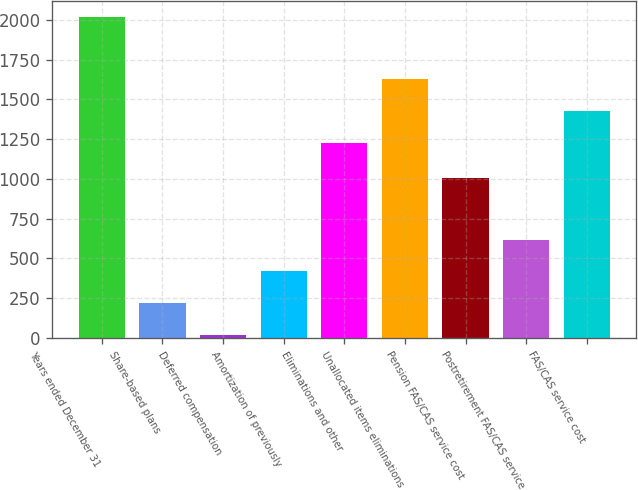Convert chart to OTSL. <chart><loc_0><loc_0><loc_500><loc_500><bar_chart><fcel>Years ended December 31<fcel>Share-based plans<fcel>Deferred compensation<fcel>Amortization of previously<fcel>Eliminations and other<fcel>Unallocated items eliminations<fcel>Pension FAS/CAS service cost<fcel>Postretirement FAS/CAS service<fcel>FAS/CAS service cost<nl><fcel>2018<fcel>218.9<fcel>19<fcel>418.8<fcel>1227<fcel>1626.8<fcel>1005<fcel>618.7<fcel>1426.9<nl></chart> 